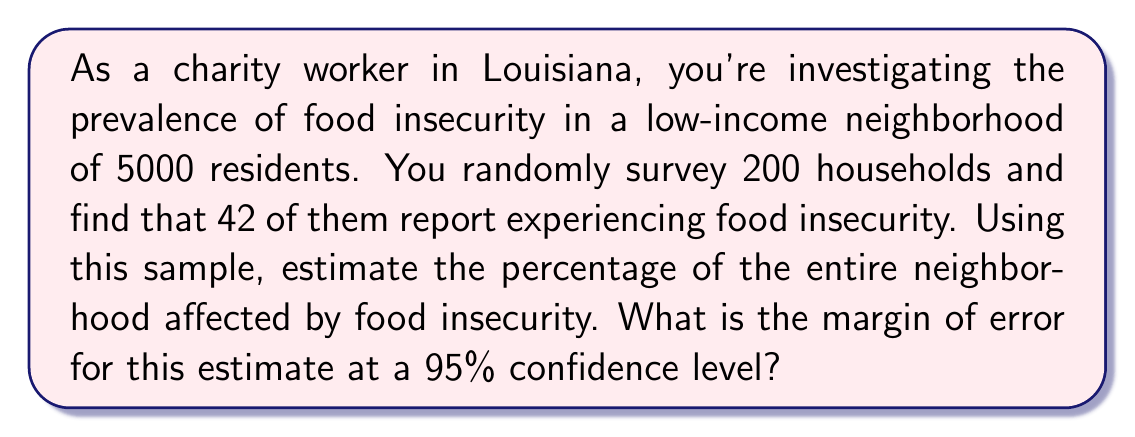Can you answer this question? To solve this problem, we'll use the concepts of sample proportion and margin of error.

1. Calculate the sample proportion:
   $p = \frac{\text{number of households reporting food insecurity}}{\text{total number of households surveyed}}$
   $p = \frac{42}{200} = 0.21$ or 21%

2. To calculate the margin of error, we use the formula:
   $\text{Margin of Error} = z \sqrt{\frac{p(1-p)}{n}}$

   Where:
   $z$ is the z-score for the desired confidence level (1.96 for 95% confidence)
   $p$ is the sample proportion
   $n$ is the sample size

3. Plug in the values:
   $\text{Margin of Error} = 1.96 \sqrt{\frac{0.21(1-0.21)}{200}}$
   
4. Simplify:
   $\text{Margin of Error} = 1.96 \sqrt{\frac{0.1659}{200}}$
   $= 1.96 \sqrt{0.0008295}$
   $= 1.96 \times 0.0288$
   $= 0.056448$

5. Convert to percentage:
   $\text{Margin of Error} = 5.64\%$

Therefore, we estimate that 21% of the neighborhood is affected by food insecurity, with a margin of error of ±5.64% at a 95% confidence level. This means we can be 95% confident that the true percentage of the neighborhood experiencing food insecurity falls between 15.36% and 26.64%.
Answer: 21% ± 5.64% 